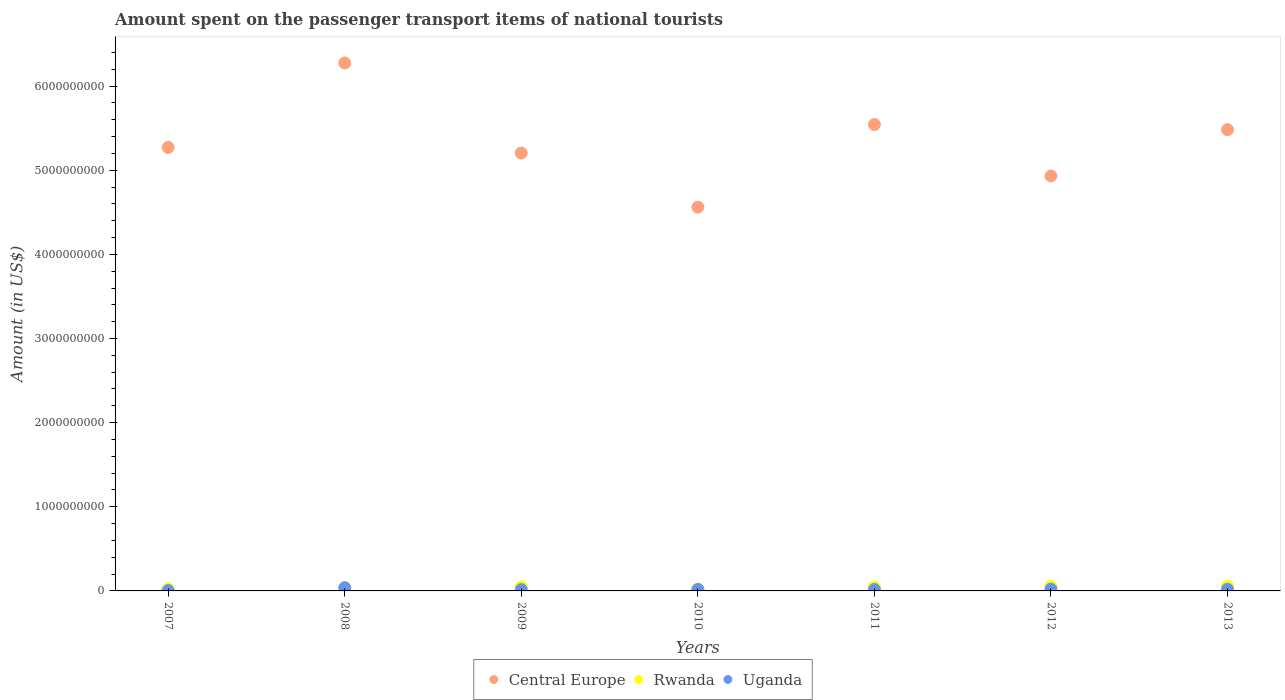What is the amount spent on the passenger transport items of national tourists in Rwanda in 2013?
Give a very brief answer. 5.70e+07. Across all years, what is the maximum amount spent on the passenger transport items of national tourists in Central Europe?
Offer a very short reply. 6.28e+09. Across all years, what is the minimum amount spent on the passenger transport items of national tourists in Central Europe?
Offer a terse response. 4.56e+09. In which year was the amount spent on the passenger transport items of national tourists in Rwanda minimum?
Provide a succinct answer. 2010. What is the total amount spent on the passenger transport items of national tourists in Central Europe in the graph?
Provide a short and direct response. 3.73e+1. What is the difference between the amount spent on the passenger transport items of national tourists in Central Europe in 2008 and that in 2011?
Your answer should be compact. 7.32e+08. What is the difference between the amount spent on the passenger transport items of national tourists in Central Europe in 2009 and the amount spent on the passenger transport items of national tourists in Rwanda in 2008?
Ensure brevity in your answer.  5.17e+09. What is the average amount spent on the passenger transport items of national tourists in Central Europe per year?
Your answer should be compact. 5.32e+09. In the year 2008, what is the difference between the amount spent on the passenger transport items of national tourists in Uganda and amount spent on the passenger transport items of national tourists in Central Europe?
Provide a succinct answer. -6.24e+09. In how many years, is the amount spent on the passenger transport items of national tourists in Rwanda greater than 2000000000 US$?
Make the answer very short. 0. What is the ratio of the amount spent on the passenger transport items of national tourists in Central Europe in 2009 to that in 2011?
Your response must be concise. 0.94. Is the difference between the amount spent on the passenger transport items of national tourists in Uganda in 2007 and 2013 greater than the difference between the amount spent on the passenger transport items of national tourists in Central Europe in 2007 and 2013?
Keep it short and to the point. Yes. What is the difference between the highest and the second highest amount spent on the passenger transport items of national tourists in Uganda?
Your answer should be very brief. 1.60e+07. What is the difference between the highest and the lowest amount spent on the passenger transport items of national tourists in Central Europe?
Your response must be concise. 1.71e+09. Does the amount spent on the passenger transport items of national tourists in Central Europe monotonically increase over the years?
Give a very brief answer. No. How many years are there in the graph?
Offer a terse response. 7. What is the difference between two consecutive major ticks on the Y-axis?
Your response must be concise. 1.00e+09. Where does the legend appear in the graph?
Your response must be concise. Bottom center. How many legend labels are there?
Keep it short and to the point. 3. What is the title of the graph?
Your answer should be very brief. Amount spent on the passenger transport items of national tourists. What is the label or title of the X-axis?
Make the answer very short. Years. What is the label or title of the Y-axis?
Offer a terse response. Amount (in US$). What is the Amount (in US$) of Central Europe in 2007?
Your answer should be very brief. 5.27e+09. What is the Amount (in US$) in Rwanda in 2007?
Your answer should be very brief. 2.50e+07. What is the Amount (in US$) in Uganda in 2007?
Your answer should be compact. 4.00e+06. What is the Amount (in US$) of Central Europe in 2008?
Your response must be concise. 6.28e+09. What is the Amount (in US$) in Rwanda in 2008?
Your answer should be very brief. 3.80e+07. What is the Amount (in US$) of Uganda in 2008?
Your response must be concise. 3.80e+07. What is the Amount (in US$) in Central Europe in 2009?
Give a very brief answer. 5.20e+09. What is the Amount (in US$) in Rwanda in 2009?
Offer a terse response. 4.90e+07. What is the Amount (in US$) in Uganda in 2009?
Your answer should be compact. 1.60e+07. What is the Amount (in US$) in Central Europe in 2010?
Your response must be concise. 4.56e+09. What is the Amount (in US$) in Rwanda in 2010?
Offer a very short reply. 2.20e+07. What is the Amount (in US$) of Uganda in 2010?
Offer a very short reply. 1.80e+07. What is the Amount (in US$) in Central Europe in 2011?
Provide a succinct answer. 5.54e+09. What is the Amount (in US$) of Rwanda in 2011?
Keep it short and to the point. 4.60e+07. What is the Amount (in US$) in Uganda in 2011?
Your response must be concise. 1.70e+07. What is the Amount (in US$) in Central Europe in 2012?
Keep it short and to the point. 4.93e+09. What is the Amount (in US$) of Rwanda in 2012?
Ensure brevity in your answer.  5.50e+07. What is the Amount (in US$) in Uganda in 2012?
Make the answer very short. 2.20e+07. What is the Amount (in US$) of Central Europe in 2013?
Your response must be concise. 5.48e+09. What is the Amount (in US$) of Rwanda in 2013?
Make the answer very short. 5.70e+07. What is the Amount (in US$) of Uganda in 2013?
Offer a terse response. 2.00e+07. Across all years, what is the maximum Amount (in US$) of Central Europe?
Provide a short and direct response. 6.28e+09. Across all years, what is the maximum Amount (in US$) of Rwanda?
Offer a very short reply. 5.70e+07. Across all years, what is the maximum Amount (in US$) of Uganda?
Keep it short and to the point. 3.80e+07. Across all years, what is the minimum Amount (in US$) of Central Europe?
Your answer should be very brief. 4.56e+09. Across all years, what is the minimum Amount (in US$) of Rwanda?
Offer a terse response. 2.20e+07. What is the total Amount (in US$) of Central Europe in the graph?
Offer a terse response. 3.73e+1. What is the total Amount (in US$) of Rwanda in the graph?
Make the answer very short. 2.92e+08. What is the total Amount (in US$) of Uganda in the graph?
Your response must be concise. 1.35e+08. What is the difference between the Amount (in US$) of Central Europe in 2007 and that in 2008?
Offer a terse response. -1.00e+09. What is the difference between the Amount (in US$) of Rwanda in 2007 and that in 2008?
Make the answer very short. -1.30e+07. What is the difference between the Amount (in US$) in Uganda in 2007 and that in 2008?
Offer a very short reply. -3.40e+07. What is the difference between the Amount (in US$) in Central Europe in 2007 and that in 2009?
Keep it short and to the point. 6.70e+07. What is the difference between the Amount (in US$) of Rwanda in 2007 and that in 2009?
Ensure brevity in your answer.  -2.40e+07. What is the difference between the Amount (in US$) in Uganda in 2007 and that in 2009?
Your answer should be compact. -1.20e+07. What is the difference between the Amount (in US$) in Central Europe in 2007 and that in 2010?
Offer a terse response. 7.10e+08. What is the difference between the Amount (in US$) in Uganda in 2007 and that in 2010?
Provide a short and direct response. -1.40e+07. What is the difference between the Amount (in US$) in Central Europe in 2007 and that in 2011?
Your answer should be compact. -2.72e+08. What is the difference between the Amount (in US$) in Rwanda in 2007 and that in 2011?
Ensure brevity in your answer.  -2.10e+07. What is the difference between the Amount (in US$) in Uganda in 2007 and that in 2011?
Your response must be concise. -1.30e+07. What is the difference between the Amount (in US$) in Central Europe in 2007 and that in 2012?
Offer a terse response. 3.39e+08. What is the difference between the Amount (in US$) in Rwanda in 2007 and that in 2012?
Keep it short and to the point. -3.00e+07. What is the difference between the Amount (in US$) of Uganda in 2007 and that in 2012?
Your response must be concise. -1.80e+07. What is the difference between the Amount (in US$) in Central Europe in 2007 and that in 2013?
Give a very brief answer. -2.11e+08. What is the difference between the Amount (in US$) of Rwanda in 2007 and that in 2013?
Provide a short and direct response. -3.20e+07. What is the difference between the Amount (in US$) of Uganda in 2007 and that in 2013?
Give a very brief answer. -1.60e+07. What is the difference between the Amount (in US$) in Central Europe in 2008 and that in 2009?
Keep it short and to the point. 1.07e+09. What is the difference between the Amount (in US$) in Rwanda in 2008 and that in 2009?
Make the answer very short. -1.10e+07. What is the difference between the Amount (in US$) in Uganda in 2008 and that in 2009?
Your response must be concise. 2.20e+07. What is the difference between the Amount (in US$) of Central Europe in 2008 and that in 2010?
Ensure brevity in your answer.  1.71e+09. What is the difference between the Amount (in US$) in Rwanda in 2008 and that in 2010?
Provide a succinct answer. 1.60e+07. What is the difference between the Amount (in US$) of Central Europe in 2008 and that in 2011?
Make the answer very short. 7.32e+08. What is the difference between the Amount (in US$) in Rwanda in 2008 and that in 2011?
Provide a succinct answer. -8.00e+06. What is the difference between the Amount (in US$) in Uganda in 2008 and that in 2011?
Provide a short and direct response. 2.10e+07. What is the difference between the Amount (in US$) in Central Europe in 2008 and that in 2012?
Keep it short and to the point. 1.34e+09. What is the difference between the Amount (in US$) in Rwanda in 2008 and that in 2012?
Make the answer very short. -1.70e+07. What is the difference between the Amount (in US$) in Uganda in 2008 and that in 2012?
Make the answer very short. 1.60e+07. What is the difference between the Amount (in US$) in Central Europe in 2008 and that in 2013?
Offer a very short reply. 7.93e+08. What is the difference between the Amount (in US$) of Rwanda in 2008 and that in 2013?
Keep it short and to the point. -1.90e+07. What is the difference between the Amount (in US$) of Uganda in 2008 and that in 2013?
Make the answer very short. 1.80e+07. What is the difference between the Amount (in US$) in Central Europe in 2009 and that in 2010?
Ensure brevity in your answer.  6.43e+08. What is the difference between the Amount (in US$) of Rwanda in 2009 and that in 2010?
Make the answer very short. 2.70e+07. What is the difference between the Amount (in US$) of Central Europe in 2009 and that in 2011?
Make the answer very short. -3.39e+08. What is the difference between the Amount (in US$) of Rwanda in 2009 and that in 2011?
Your response must be concise. 3.00e+06. What is the difference between the Amount (in US$) of Uganda in 2009 and that in 2011?
Ensure brevity in your answer.  -1.00e+06. What is the difference between the Amount (in US$) of Central Europe in 2009 and that in 2012?
Make the answer very short. 2.72e+08. What is the difference between the Amount (in US$) in Rwanda in 2009 and that in 2012?
Your response must be concise. -6.00e+06. What is the difference between the Amount (in US$) in Uganda in 2009 and that in 2012?
Your answer should be very brief. -6.00e+06. What is the difference between the Amount (in US$) in Central Europe in 2009 and that in 2013?
Give a very brief answer. -2.78e+08. What is the difference between the Amount (in US$) in Rwanda in 2009 and that in 2013?
Provide a short and direct response. -8.00e+06. What is the difference between the Amount (in US$) of Uganda in 2009 and that in 2013?
Provide a short and direct response. -4.00e+06. What is the difference between the Amount (in US$) in Central Europe in 2010 and that in 2011?
Make the answer very short. -9.82e+08. What is the difference between the Amount (in US$) of Rwanda in 2010 and that in 2011?
Your answer should be very brief. -2.40e+07. What is the difference between the Amount (in US$) in Central Europe in 2010 and that in 2012?
Provide a succinct answer. -3.71e+08. What is the difference between the Amount (in US$) of Rwanda in 2010 and that in 2012?
Your response must be concise. -3.30e+07. What is the difference between the Amount (in US$) in Uganda in 2010 and that in 2012?
Your response must be concise. -4.00e+06. What is the difference between the Amount (in US$) of Central Europe in 2010 and that in 2013?
Make the answer very short. -9.21e+08. What is the difference between the Amount (in US$) in Rwanda in 2010 and that in 2013?
Offer a terse response. -3.50e+07. What is the difference between the Amount (in US$) of Uganda in 2010 and that in 2013?
Offer a very short reply. -2.00e+06. What is the difference between the Amount (in US$) of Central Europe in 2011 and that in 2012?
Your answer should be compact. 6.11e+08. What is the difference between the Amount (in US$) in Rwanda in 2011 and that in 2012?
Offer a very short reply. -9.00e+06. What is the difference between the Amount (in US$) of Uganda in 2011 and that in 2012?
Ensure brevity in your answer.  -5.00e+06. What is the difference between the Amount (in US$) in Central Europe in 2011 and that in 2013?
Give a very brief answer. 6.10e+07. What is the difference between the Amount (in US$) in Rwanda in 2011 and that in 2013?
Ensure brevity in your answer.  -1.10e+07. What is the difference between the Amount (in US$) in Central Europe in 2012 and that in 2013?
Make the answer very short. -5.50e+08. What is the difference between the Amount (in US$) of Rwanda in 2012 and that in 2013?
Provide a short and direct response. -2.00e+06. What is the difference between the Amount (in US$) in Uganda in 2012 and that in 2013?
Keep it short and to the point. 2.00e+06. What is the difference between the Amount (in US$) of Central Europe in 2007 and the Amount (in US$) of Rwanda in 2008?
Your answer should be very brief. 5.23e+09. What is the difference between the Amount (in US$) in Central Europe in 2007 and the Amount (in US$) in Uganda in 2008?
Your answer should be compact. 5.23e+09. What is the difference between the Amount (in US$) in Rwanda in 2007 and the Amount (in US$) in Uganda in 2008?
Give a very brief answer. -1.30e+07. What is the difference between the Amount (in US$) of Central Europe in 2007 and the Amount (in US$) of Rwanda in 2009?
Make the answer very short. 5.22e+09. What is the difference between the Amount (in US$) in Central Europe in 2007 and the Amount (in US$) in Uganda in 2009?
Keep it short and to the point. 5.26e+09. What is the difference between the Amount (in US$) of Rwanda in 2007 and the Amount (in US$) of Uganda in 2009?
Give a very brief answer. 9.00e+06. What is the difference between the Amount (in US$) of Central Europe in 2007 and the Amount (in US$) of Rwanda in 2010?
Make the answer very short. 5.25e+09. What is the difference between the Amount (in US$) of Central Europe in 2007 and the Amount (in US$) of Uganda in 2010?
Ensure brevity in your answer.  5.25e+09. What is the difference between the Amount (in US$) in Central Europe in 2007 and the Amount (in US$) in Rwanda in 2011?
Provide a short and direct response. 5.22e+09. What is the difference between the Amount (in US$) of Central Europe in 2007 and the Amount (in US$) of Uganda in 2011?
Provide a short and direct response. 5.25e+09. What is the difference between the Amount (in US$) in Central Europe in 2007 and the Amount (in US$) in Rwanda in 2012?
Ensure brevity in your answer.  5.22e+09. What is the difference between the Amount (in US$) in Central Europe in 2007 and the Amount (in US$) in Uganda in 2012?
Make the answer very short. 5.25e+09. What is the difference between the Amount (in US$) in Rwanda in 2007 and the Amount (in US$) in Uganda in 2012?
Provide a short and direct response. 3.00e+06. What is the difference between the Amount (in US$) of Central Europe in 2007 and the Amount (in US$) of Rwanda in 2013?
Provide a succinct answer. 5.21e+09. What is the difference between the Amount (in US$) of Central Europe in 2007 and the Amount (in US$) of Uganda in 2013?
Your answer should be compact. 5.25e+09. What is the difference between the Amount (in US$) in Rwanda in 2007 and the Amount (in US$) in Uganda in 2013?
Your response must be concise. 5.00e+06. What is the difference between the Amount (in US$) of Central Europe in 2008 and the Amount (in US$) of Rwanda in 2009?
Your response must be concise. 6.23e+09. What is the difference between the Amount (in US$) in Central Europe in 2008 and the Amount (in US$) in Uganda in 2009?
Ensure brevity in your answer.  6.26e+09. What is the difference between the Amount (in US$) of Rwanda in 2008 and the Amount (in US$) of Uganda in 2009?
Offer a terse response. 2.20e+07. What is the difference between the Amount (in US$) in Central Europe in 2008 and the Amount (in US$) in Rwanda in 2010?
Provide a short and direct response. 6.25e+09. What is the difference between the Amount (in US$) in Central Europe in 2008 and the Amount (in US$) in Uganda in 2010?
Your answer should be very brief. 6.26e+09. What is the difference between the Amount (in US$) in Rwanda in 2008 and the Amount (in US$) in Uganda in 2010?
Your answer should be very brief. 2.00e+07. What is the difference between the Amount (in US$) of Central Europe in 2008 and the Amount (in US$) of Rwanda in 2011?
Give a very brief answer. 6.23e+09. What is the difference between the Amount (in US$) of Central Europe in 2008 and the Amount (in US$) of Uganda in 2011?
Provide a succinct answer. 6.26e+09. What is the difference between the Amount (in US$) of Rwanda in 2008 and the Amount (in US$) of Uganda in 2011?
Offer a very short reply. 2.10e+07. What is the difference between the Amount (in US$) of Central Europe in 2008 and the Amount (in US$) of Rwanda in 2012?
Your answer should be very brief. 6.22e+09. What is the difference between the Amount (in US$) in Central Europe in 2008 and the Amount (in US$) in Uganda in 2012?
Your response must be concise. 6.25e+09. What is the difference between the Amount (in US$) of Rwanda in 2008 and the Amount (in US$) of Uganda in 2012?
Offer a very short reply. 1.60e+07. What is the difference between the Amount (in US$) of Central Europe in 2008 and the Amount (in US$) of Rwanda in 2013?
Make the answer very short. 6.22e+09. What is the difference between the Amount (in US$) in Central Europe in 2008 and the Amount (in US$) in Uganda in 2013?
Offer a very short reply. 6.26e+09. What is the difference between the Amount (in US$) in Rwanda in 2008 and the Amount (in US$) in Uganda in 2013?
Ensure brevity in your answer.  1.80e+07. What is the difference between the Amount (in US$) in Central Europe in 2009 and the Amount (in US$) in Rwanda in 2010?
Give a very brief answer. 5.18e+09. What is the difference between the Amount (in US$) of Central Europe in 2009 and the Amount (in US$) of Uganda in 2010?
Your answer should be compact. 5.19e+09. What is the difference between the Amount (in US$) of Rwanda in 2009 and the Amount (in US$) of Uganda in 2010?
Your answer should be very brief. 3.10e+07. What is the difference between the Amount (in US$) of Central Europe in 2009 and the Amount (in US$) of Rwanda in 2011?
Your answer should be compact. 5.16e+09. What is the difference between the Amount (in US$) of Central Europe in 2009 and the Amount (in US$) of Uganda in 2011?
Give a very brief answer. 5.19e+09. What is the difference between the Amount (in US$) in Rwanda in 2009 and the Amount (in US$) in Uganda in 2011?
Provide a short and direct response. 3.20e+07. What is the difference between the Amount (in US$) in Central Europe in 2009 and the Amount (in US$) in Rwanda in 2012?
Make the answer very short. 5.15e+09. What is the difference between the Amount (in US$) in Central Europe in 2009 and the Amount (in US$) in Uganda in 2012?
Offer a very short reply. 5.18e+09. What is the difference between the Amount (in US$) in Rwanda in 2009 and the Amount (in US$) in Uganda in 2012?
Offer a terse response. 2.70e+07. What is the difference between the Amount (in US$) of Central Europe in 2009 and the Amount (in US$) of Rwanda in 2013?
Your answer should be compact. 5.15e+09. What is the difference between the Amount (in US$) of Central Europe in 2009 and the Amount (in US$) of Uganda in 2013?
Offer a very short reply. 5.18e+09. What is the difference between the Amount (in US$) of Rwanda in 2009 and the Amount (in US$) of Uganda in 2013?
Ensure brevity in your answer.  2.90e+07. What is the difference between the Amount (in US$) of Central Europe in 2010 and the Amount (in US$) of Rwanda in 2011?
Give a very brief answer. 4.52e+09. What is the difference between the Amount (in US$) of Central Europe in 2010 and the Amount (in US$) of Uganda in 2011?
Ensure brevity in your answer.  4.54e+09. What is the difference between the Amount (in US$) of Rwanda in 2010 and the Amount (in US$) of Uganda in 2011?
Ensure brevity in your answer.  5.00e+06. What is the difference between the Amount (in US$) of Central Europe in 2010 and the Amount (in US$) of Rwanda in 2012?
Your answer should be very brief. 4.51e+09. What is the difference between the Amount (in US$) in Central Europe in 2010 and the Amount (in US$) in Uganda in 2012?
Give a very brief answer. 4.54e+09. What is the difference between the Amount (in US$) of Central Europe in 2010 and the Amount (in US$) of Rwanda in 2013?
Make the answer very short. 4.50e+09. What is the difference between the Amount (in US$) in Central Europe in 2010 and the Amount (in US$) in Uganda in 2013?
Your response must be concise. 4.54e+09. What is the difference between the Amount (in US$) in Rwanda in 2010 and the Amount (in US$) in Uganda in 2013?
Your answer should be compact. 2.00e+06. What is the difference between the Amount (in US$) of Central Europe in 2011 and the Amount (in US$) of Rwanda in 2012?
Your response must be concise. 5.49e+09. What is the difference between the Amount (in US$) of Central Europe in 2011 and the Amount (in US$) of Uganda in 2012?
Ensure brevity in your answer.  5.52e+09. What is the difference between the Amount (in US$) of Rwanda in 2011 and the Amount (in US$) of Uganda in 2012?
Provide a succinct answer. 2.40e+07. What is the difference between the Amount (in US$) of Central Europe in 2011 and the Amount (in US$) of Rwanda in 2013?
Your answer should be compact. 5.49e+09. What is the difference between the Amount (in US$) of Central Europe in 2011 and the Amount (in US$) of Uganda in 2013?
Give a very brief answer. 5.52e+09. What is the difference between the Amount (in US$) of Rwanda in 2011 and the Amount (in US$) of Uganda in 2013?
Give a very brief answer. 2.60e+07. What is the difference between the Amount (in US$) of Central Europe in 2012 and the Amount (in US$) of Rwanda in 2013?
Give a very brief answer. 4.88e+09. What is the difference between the Amount (in US$) in Central Europe in 2012 and the Amount (in US$) in Uganda in 2013?
Offer a terse response. 4.91e+09. What is the difference between the Amount (in US$) of Rwanda in 2012 and the Amount (in US$) of Uganda in 2013?
Keep it short and to the point. 3.50e+07. What is the average Amount (in US$) in Central Europe per year?
Offer a very short reply. 5.32e+09. What is the average Amount (in US$) of Rwanda per year?
Provide a short and direct response. 4.17e+07. What is the average Amount (in US$) in Uganda per year?
Keep it short and to the point. 1.93e+07. In the year 2007, what is the difference between the Amount (in US$) in Central Europe and Amount (in US$) in Rwanda?
Your answer should be very brief. 5.25e+09. In the year 2007, what is the difference between the Amount (in US$) of Central Europe and Amount (in US$) of Uganda?
Your response must be concise. 5.27e+09. In the year 2007, what is the difference between the Amount (in US$) in Rwanda and Amount (in US$) in Uganda?
Provide a short and direct response. 2.10e+07. In the year 2008, what is the difference between the Amount (in US$) in Central Europe and Amount (in US$) in Rwanda?
Keep it short and to the point. 6.24e+09. In the year 2008, what is the difference between the Amount (in US$) in Central Europe and Amount (in US$) in Uganda?
Ensure brevity in your answer.  6.24e+09. In the year 2008, what is the difference between the Amount (in US$) of Rwanda and Amount (in US$) of Uganda?
Your answer should be very brief. 0. In the year 2009, what is the difference between the Amount (in US$) in Central Europe and Amount (in US$) in Rwanda?
Your answer should be very brief. 5.16e+09. In the year 2009, what is the difference between the Amount (in US$) of Central Europe and Amount (in US$) of Uganda?
Offer a very short reply. 5.19e+09. In the year 2009, what is the difference between the Amount (in US$) in Rwanda and Amount (in US$) in Uganda?
Provide a short and direct response. 3.30e+07. In the year 2010, what is the difference between the Amount (in US$) of Central Europe and Amount (in US$) of Rwanda?
Your answer should be very brief. 4.54e+09. In the year 2010, what is the difference between the Amount (in US$) in Central Europe and Amount (in US$) in Uganda?
Your response must be concise. 4.54e+09. In the year 2010, what is the difference between the Amount (in US$) in Rwanda and Amount (in US$) in Uganda?
Offer a very short reply. 4.00e+06. In the year 2011, what is the difference between the Amount (in US$) in Central Europe and Amount (in US$) in Rwanda?
Your answer should be compact. 5.50e+09. In the year 2011, what is the difference between the Amount (in US$) in Central Europe and Amount (in US$) in Uganda?
Your response must be concise. 5.53e+09. In the year 2011, what is the difference between the Amount (in US$) in Rwanda and Amount (in US$) in Uganda?
Your answer should be compact. 2.90e+07. In the year 2012, what is the difference between the Amount (in US$) in Central Europe and Amount (in US$) in Rwanda?
Your answer should be compact. 4.88e+09. In the year 2012, what is the difference between the Amount (in US$) of Central Europe and Amount (in US$) of Uganda?
Keep it short and to the point. 4.91e+09. In the year 2012, what is the difference between the Amount (in US$) in Rwanda and Amount (in US$) in Uganda?
Keep it short and to the point. 3.30e+07. In the year 2013, what is the difference between the Amount (in US$) of Central Europe and Amount (in US$) of Rwanda?
Your answer should be compact. 5.42e+09. In the year 2013, what is the difference between the Amount (in US$) of Central Europe and Amount (in US$) of Uganda?
Your response must be concise. 5.46e+09. In the year 2013, what is the difference between the Amount (in US$) in Rwanda and Amount (in US$) in Uganda?
Your answer should be compact. 3.70e+07. What is the ratio of the Amount (in US$) of Central Europe in 2007 to that in 2008?
Your answer should be compact. 0.84. What is the ratio of the Amount (in US$) of Rwanda in 2007 to that in 2008?
Provide a short and direct response. 0.66. What is the ratio of the Amount (in US$) in Uganda in 2007 to that in 2008?
Provide a short and direct response. 0.11. What is the ratio of the Amount (in US$) of Central Europe in 2007 to that in 2009?
Make the answer very short. 1.01. What is the ratio of the Amount (in US$) of Rwanda in 2007 to that in 2009?
Provide a succinct answer. 0.51. What is the ratio of the Amount (in US$) in Central Europe in 2007 to that in 2010?
Provide a short and direct response. 1.16. What is the ratio of the Amount (in US$) in Rwanda in 2007 to that in 2010?
Provide a short and direct response. 1.14. What is the ratio of the Amount (in US$) in Uganda in 2007 to that in 2010?
Offer a terse response. 0.22. What is the ratio of the Amount (in US$) of Central Europe in 2007 to that in 2011?
Your response must be concise. 0.95. What is the ratio of the Amount (in US$) of Rwanda in 2007 to that in 2011?
Provide a short and direct response. 0.54. What is the ratio of the Amount (in US$) of Uganda in 2007 to that in 2011?
Provide a succinct answer. 0.24. What is the ratio of the Amount (in US$) in Central Europe in 2007 to that in 2012?
Ensure brevity in your answer.  1.07. What is the ratio of the Amount (in US$) of Rwanda in 2007 to that in 2012?
Offer a very short reply. 0.45. What is the ratio of the Amount (in US$) of Uganda in 2007 to that in 2012?
Offer a very short reply. 0.18. What is the ratio of the Amount (in US$) of Central Europe in 2007 to that in 2013?
Make the answer very short. 0.96. What is the ratio of the Amount (in US$) of Rwanda in 2007 to that in 2013?
Keep it short and to the point. 0.44. What is the ratio of the Amount (in US$) of Uganda in 2007 to that in 2013?
Keep it short and to the point. 0.2. What is the ratio of the Amount (in US$) of Central Europe in 2008 to that in 2009?
Offer a terse response. 1.21. What is the ratio of the Amount (in US$) of Rwanda in 2008 to that in 2009?
Your answer should be very brief. 0.78. What is the ratio of the Amount (in US$) of Uganda in 2008 to that in 2009?
Offer a very short reply. 2.38. What is the ratio of the Amount (in US$) in Central Europe in 2008 to that in 2010?
Provide a succinct answer. 1.38. What is the ratio of the Amount (in US$) of Rwanda in 2008 to that in 2010?
Keep it short and to the point. 1.73. What is the ratio of the Amount (in US$) of Uganda in 2008 to that in 2010?
Your answer should be very brief. 2.11. What is the ratio of the Amount (in US$) in Central Europe in 2008 to that in 2011?
Give a very brief answer. 1.13. What is the ratio of the Amount (in US$) in Rwanda in 2008 to that in 2011?
Offer a very short reply. 0.83. What is the ratio of the Amount (in US$) in Uganda in 2008 to that in 2011?
Ensure brevity in your answer.  2.24. What is the ratio of the Amount (in US$) of Central Europe in 2008 to that in 2012?
Keep it short and to the point. 1.27. What is the ratio of the Amount (in US$) of Rwanda in 2008 to that in 2012?
Offer a very short reply. 0.69. What is the ratio of the Amount (in US$) of Uganda in 2008 to that in 2012?
Your answer should be compact. 1.73. What is the ratio of the Amount (in US$) in Central Europe in 2008 to that in 2013?
Keep it short and to the point. 1.14. What is the ratio of the Amount (in US$) of Rwanda in 2008 to that in 2013?
Offer a very short reply. 0.67. What is the ratio of the Amount (in US$) of Central Europe in 2009 to that in 2010?
Provide a short and direct response. 1.14. What is the ratio of the Amount (in US$) in Rwanda in 2009 to that in 2010?
Provide a succinct answer. 2.23. What is the ratio of the Amount (in US$) in Central Europe in 2009 to that in 2011?
Provide a short and direct response. 0.94. What is the ratio of the Amount (in US$) in Rwanda in 2009 to that in 2011?
Your response must be concise. 1.07. What is the ratio of the Amount (in US$) in Central Europe in 2009 to that in 2012?
Offer a very short reply. 1.06. What is the ratio of the Amount (in US$) in Rwanda in 2009 to that in 2012?
Keep it short and to the point. 0.89. What is the ratio of the Amount (in US$) in Uganda in 2009 to that in 2012?
Your answer should be compact. 0.73. What is the ratio of the Amount (in US$) in Central Europe in 2009 to that in 2013?
Provide a succinct answer. 0.95. What is the ratio of the Amount (in US$) of Rwanda in 2009 to that in 2013?
Give a very brief answer. 0.86. What is the ratio of the Amount (in US$) in Uganda in 2009 to that in 2013?
Your response must be concise. 0.8. What is the ratio of the Amount (in US$) of Central Europe in 2010 to that in 2011?
Offer a very short reply. 0.82. What is the ratio of the Amount (in US$) of Rwanda in 2010 to that in 2011?
Your answer should be very brief. 0.48. What is the ratio of the Amount (in US$) of Uganda in 2010 to that in 2011?
Keep it short and to the point. 1.06. What is the ratio of the Amount (in US$) of Central Europe in 2010 to that in 2012?
Offer a very short reply. 0.92. What is the ratio of the Amount (in US$) in Rwanda in 2010 to that in 2012?
Keep it short and to the point. 0.4. What is the ratio of the Amount (in US$) of Uganda in 2010 to that in 2012?
Give a very brief answer. 0.82. What is the ratio of the Amount (in US$) in Central Europe in 2010 to that in 2013?
Ensure brevity in your answer.  0.83. What is the ratio of the Amount (in US$) of Rwanda in 2010 to that in 2013?
Keep it short and to the point. 0.39. What is the ratio of the Amount (in US$) in Central Europe in 2011 to that in 2012?
Your response must be concise. 1.12. What is the ratio of the Amount (in US$) of Rwanda in 2011 to that in 2012?
Offer a very short reply. 0.84. What is the ratio of the Amount (in US$) of Uganda in 2011 to that in 2012?
Your answer should be compact. 0.77. What is the ratio of the Amount (in US$) of Central Europe in 2011 to that in 2013?
Give a very brief answer. 1.01. What is the ratio of the Amount (in US$) in Rwanda in 2011 to that in 2013?
Provide a succinct answer. 0.81. What is the ratio of the Amount (in US$) in Central Europe in 2012 to that in 2013?
Keep it short and to the point. 0.9. What is the ratio of the Amount (in US$) in Rwanda in 2012 to that in 2013?
Your answer should be compact. 0.96. What is the difference between the highest and the second highest Amount (in US$) of Central Europe?
Your response must be concise. 7.32e+08. What is the difference between the highest and the second highest Amount (in US$) in Rwanda?
Provide a succinct answer. 2.00e+06. What is the difference between the highest and the second highest Amount (in US$) in Uganda?
Ensure brevity in your answer.  1.60e+07. What is the difference between the highest and the lowest Amount (in US$) of Central Europe?
Your answer should be compact. 1.71e+09. What is the difference between the highest and the lowest Amount (in US$) of Rwanda?
Your answer should be very brief. 3.50e+07. What is the difference between the highest and the lowest Amount (in US$) in Uganda?
Provide a short and direct response. 3.40e+07. 